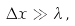<formula> <loc_0><loc_0><loc_500><loc_500>\Delta x \gg \lambda \, ,</formula> 